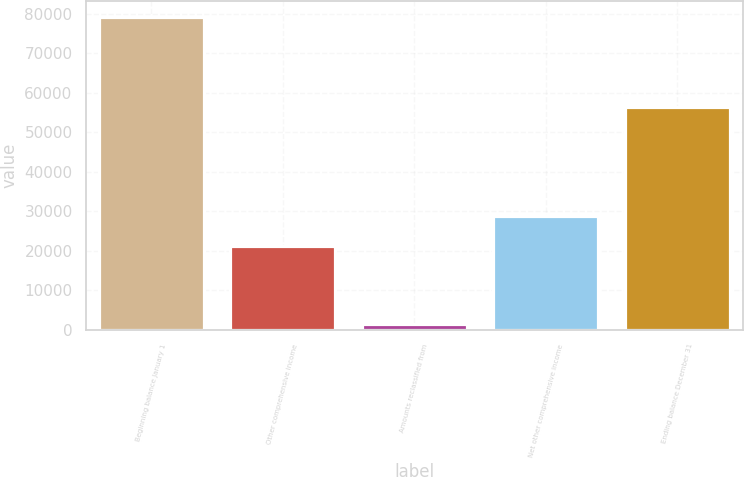Convert chart to OTSL. <chart><loc_0><loc_0><loc_500><loc_500><bar_chart><fcel>Beginning balance January 1<fcel>Other comprehensive income<fcel>Amounts reclassified from<fcel>Net other comprehensive income<fcel>Ending balance December 31<nl><fcel>79223<fcel>21180<fcel>1631<fcel>28939.2<fcel>56412<nl></chart> 